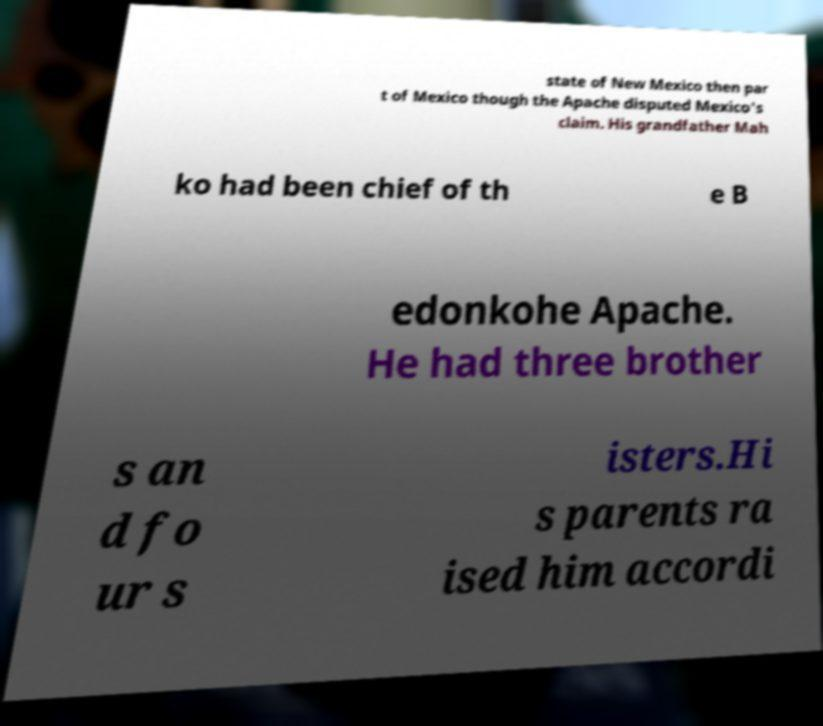There's text embedded in this image that I need extracted. Can you transcribe it verbatim? state of New Mexico then par t of Mexico though the Apache disputed Mexico's claim. His grandfather Mah ko had been chief of th e B edonkohe Apache. He had three brother s an d fo ur s isters.Hi s parents ra ised him accordi 